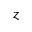Convert formula to latex. <formula><loc_0><loc_0><loc_500><loc_500>z</formula> 